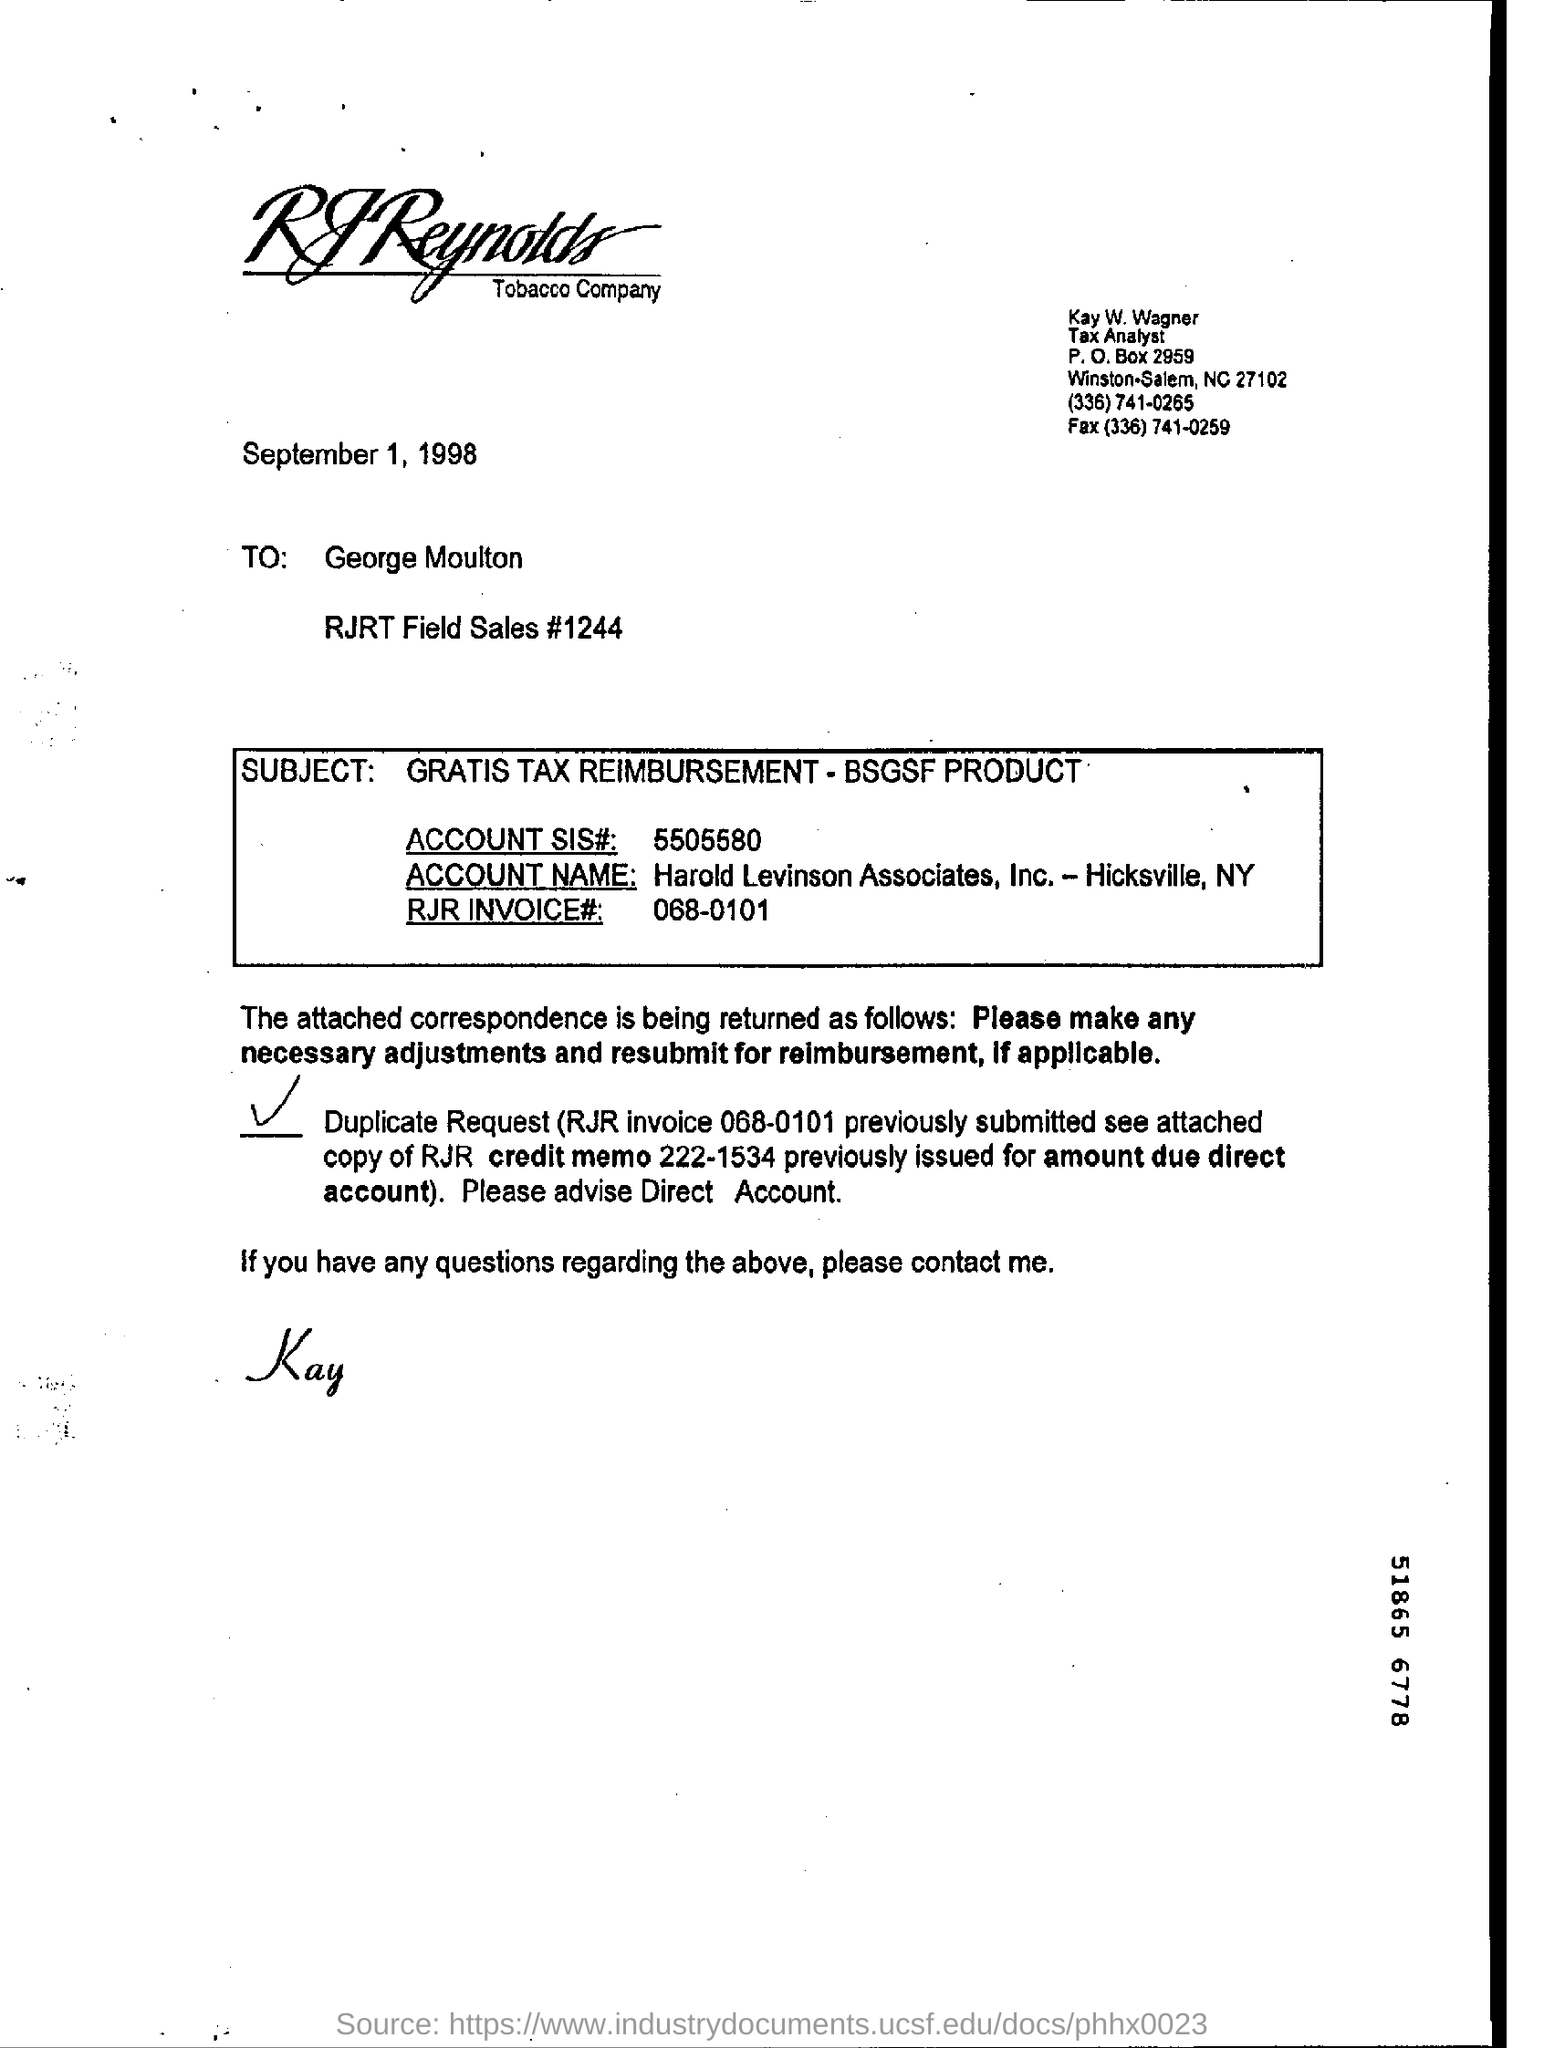What is the p.o box number in the letter?
Provide a short and direct response. 2959. What is the fax number in the letter?
Your response must be concise. (336) 741-0259. What is the sis account number?
Give a very brief answer. 5505580. What is the rjr invoice number?
Make the answer very short. 068-0101. 